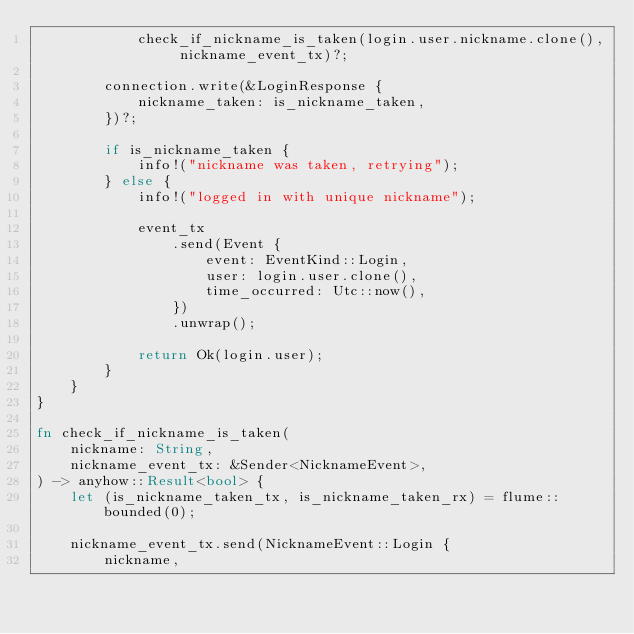<code> <loc_0><loc_0><loc_500><loc_500><_Rust_>            check_if_nickname_is_taken(login.user.nickname.clone(), nickname_event_tx)?;

        connection.write(&LoginResponse {
            nickname_taken: is_nickname_taken,
        })?;

        if is_nickname_taken {
            info!("nickname was taken, retrying");
        } else {
            info!("logged in with unique nickname");

            event_tx
                .send(Event {
                    event: EventKind::Login,
                    user: login.user.clone(),
                    time_occurred: Utc::now(),
                })
                .unwrap();

            return Ok(login.user);
        }
    }
}

fn check_if_nickname_is_taken(
    nickname: String,
    nickname_event_tx: &Sender<NicknameEvent>,
) -> anyhow::Result<bool> {
    let (is_nickname_taken_tx, is_nickname_taken_rx) = flume::bounded(0);

    nickname_event_tx.send(NicknameEvent::Login {
        nickname,</code> 